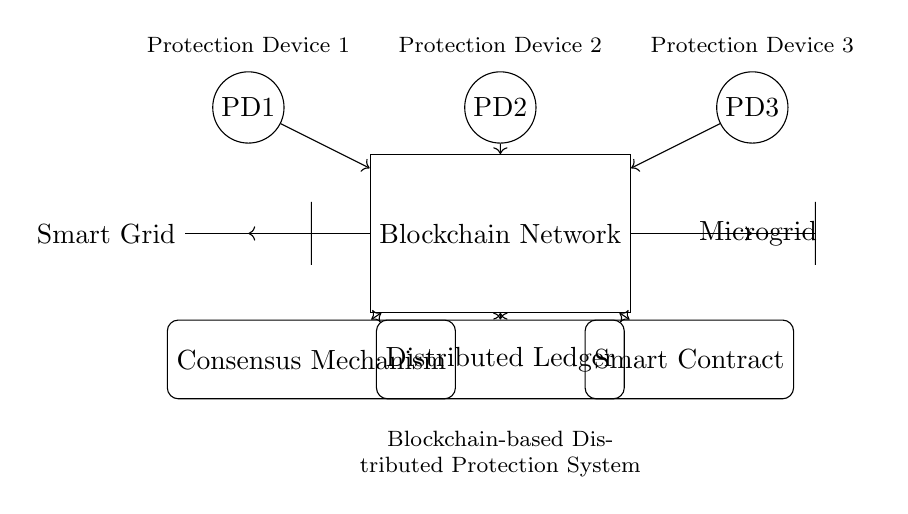What is the function of the blockchain network? The blockchain network serves as a digital platform for secure and transparent communication between the protection devices in the smart grid and microgrid. It enables decentralized data storage and processing to facilitate distributed protection mechanisms.
Answer: Secure communication How many protection devices are depicted in the circuit? There are three protection devices shown in the circuit diagram, specifically labeled as PD1, PD2, and PD3. Each device is represented by a circle and is connected to the blockchain network.
Answer: Three What is the role of the distributed ledger? The distributed ledger functions as a record-keeping system that maintains a tamper-proof history of transactions and events occurring within the blockchain network related to the protection system of the smart grid and microgrid.
Answer: Record-keeping How do protection devices interact with the blockchain network? Each protection device, identified as PD1, PD2, and PD3, sends data to the blockchain network, indicating that they are connected and communicating through directed arrows. This interaction allows for coordinated protection actions and data sharing.
Answer: Data sending Which component is responsible for executing the smart contract? The component that executes the smart contract is labeled as "Smart Contract" in the circuit, indicating its role in facilitating automated agreements and conditions based on the data received from the blockchain network and protection devices.
Answer: Smart Contract What does the consensus mechanism ensure in this setup? The consensus mechanism ensures that all nodes within the blockchain network agree on the shared data and the actions to be taken, which is crucial for maintaining reliability and security in the distributed protection system for smart grids and microgrids.
Answer: Agreement 